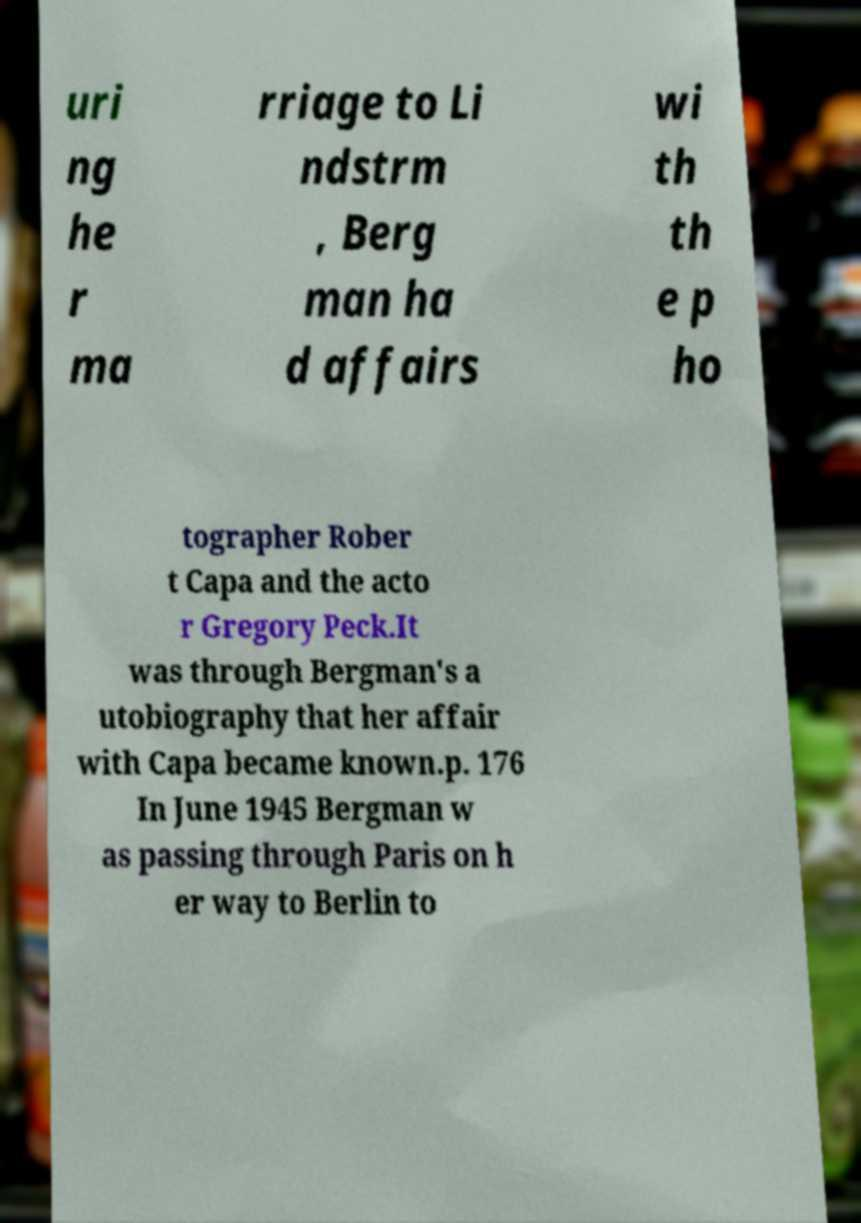Could you extract and type out the text from this image? uri ng he r ma rriage to Li ndstrm , Berg man ha d affairs wi th th e p ho tographer Rober t Capa and the acto r Gregory Peck.It was through Bergman's a utobiography that her affair with Capa became known.p. 176 In June 1945 Bergman w as passing through Paris on h er way to Berlin to 